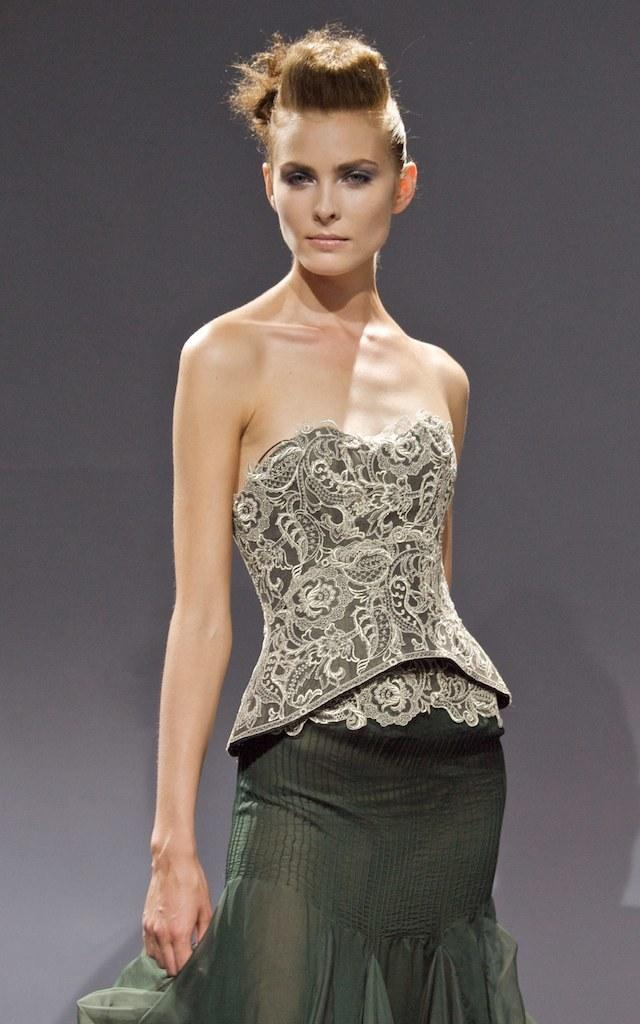Who is the main subject in the image? There is a woman in the image. What is the woman doing in the image? The woman is standing. What is the plot of the story being told in the image? There is no story being told in the image, as it is a simple photograph of a woman standing. What type of footwear is the woman wearing in the image? The provided facts do not mention any footwear, so we cannot determine what type of shoes the woman is wearing. 